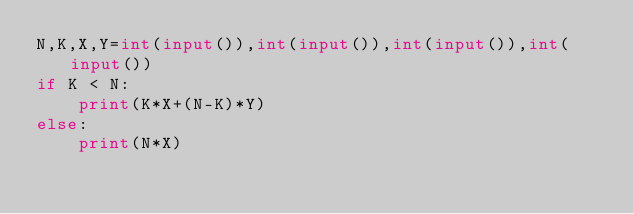<code> <loc_0><loc_0><loc_500><loc_500><_Python_>N,K,X,Y=int(input()),int(input()),int(input()),int(input())
if K < N:
    print(K*X+(N-K)*Y)
else:
    print(N*X)</code> 